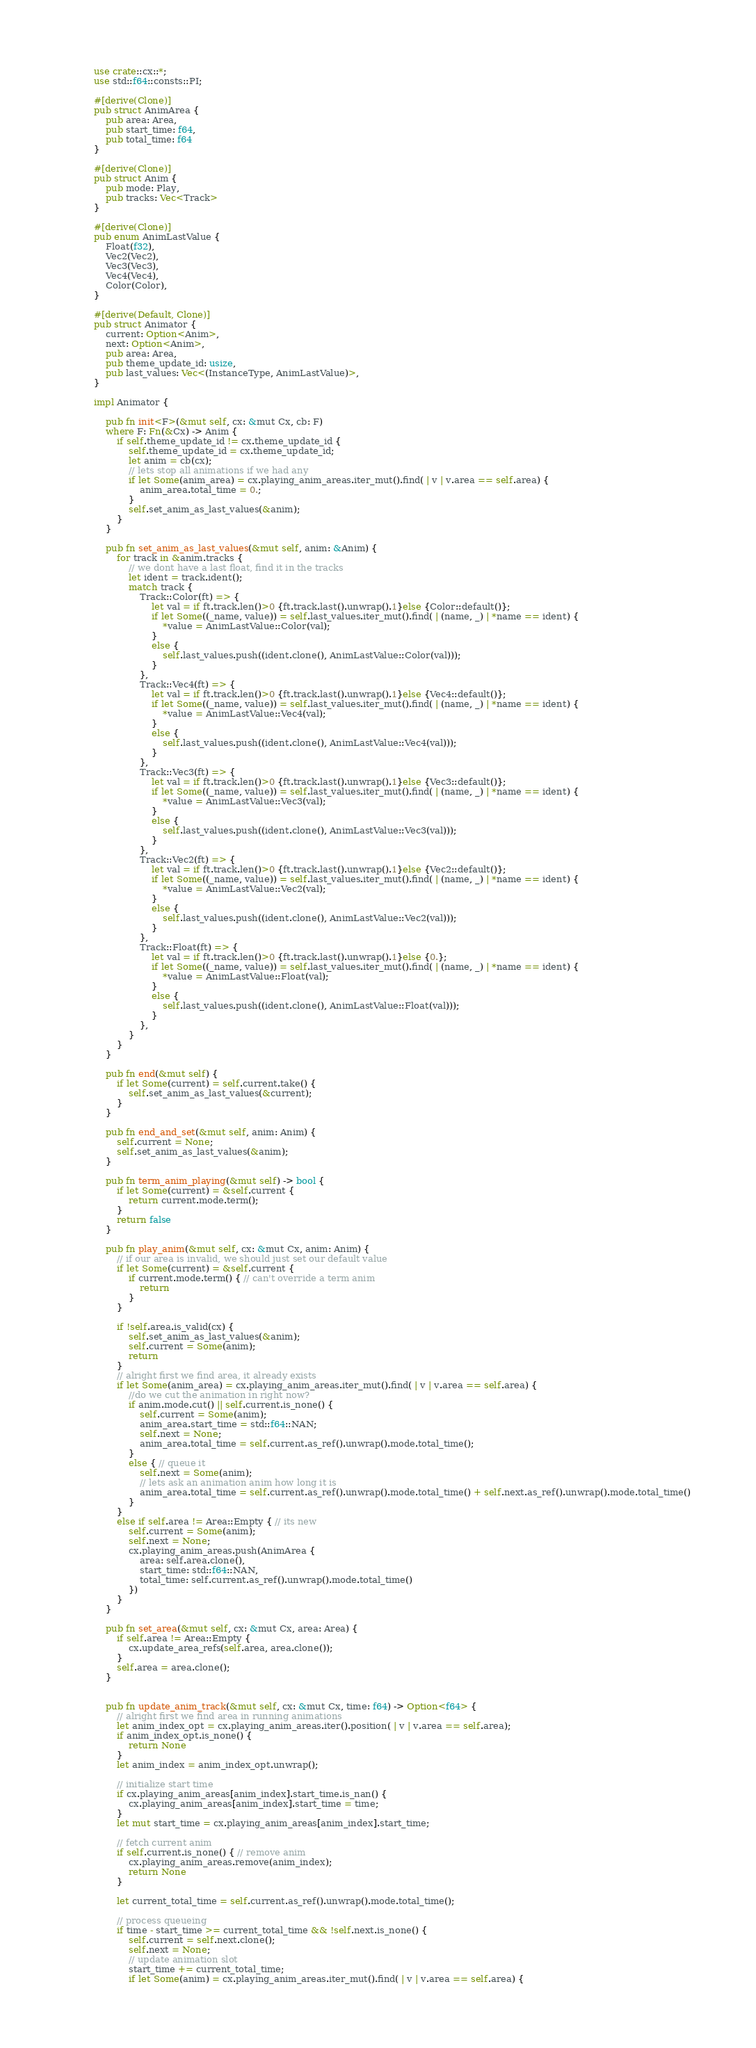Convert code to text. <code><loc_0><loc_0><loc_500><loc_500><_Rust_>use crate::cx::*;
use std::f64::consts::PI;

#[derive(Clone)]
pub struct AnimArea {
    pub area: Area,
    pub start_time: f64,
    pub total_time: f64
}

#[derive(Clone)]
pub struct Anim {
    pub mode: Play,
    pub tracks: Vec<Track>
}

#[derive(Clone)]
pub enum AnimLastValue {
    Float(f32),
    Vec2(Vec2),
    Vec3(Vec3),
    Vec4(Vec4),
    Color(Color),
}

#[derive(Default, Clone)]
pub struct Animator {
    current: Option<Anim>,
    next: Option<Anim>,
    pub area: Area,
    pub theme_update_id: usize,
    pub last_values: Vec<(InstanceType, AnimLastValue)>,
}

impl Animator {

    pub fn init<F>(&mut self, cx: &mut Cx, cb: F)
    where F: Fn(&Cx) -> Anim {
        if self.theme_update_id != cx.theme_update_id {
            self.theme_update_id = cx.theme_update_id;
            let anim = cb(cx);
            // lets stop all animations if we had any
            if let Some(anim_area) = cx.playing_anim_areas.iter_mut().find( | v | v.area == self.area) {
                anim_area.total_time = 0.;
            }
            self.set_anim_as_last_values(&anim);
        }
    }
    
    pub fn set_anim_as_last_values(&mut self, anim: &Anim) {
        for track in &anim.tracks {
            // we dont have a last float, find it in the tracks
            let ident = track.ident();
            match track {
                Track::Color(ft) => {
                    let val = if ft.track.len()>0 {ft.track.last().unwrap().1}else {Color::default()};
                    if let Some((_name, value)) = self.last_values.iter_mut().find( | (name, _) | *name == ident) {
                        *value = AnimLastValue::Color(val);
                    }
                    else {
                        self.last_values.push((ident.clone(), AnimLastValue::Color(val)));
                    }
                },
                Track::Vec4(ft) => {
                    let val = if ft.track.len()>0 {ft.track.last().unwrap().1}else {Vec4::default()};
                    if let Some((_name, value)) = self.last_values.iter_mut().find( | (name, _) | *name == ident) {
                        *value = AnimLastValue::Vec4(val);
                    }
                    else {
                        self.last_values.push((ident.clone(), AnimLastValue::Vec4(val)));
                    }
                },
                Track::Vec3(ft) => {
                    let val = if ft.track.len()>0 {ft.track.last().unwrap().1}else {Vec3::default()};
                    if let Some((_name, value)) = self.last_values.iter_mut().find( | (name, _) | *name == ident) {
                        *value = AnimLastValue::Vec3(val);
                    }
                    else {
                        self.last_values.push((ident.clone(), AnimLastValue::Vec3(val)));
                    }
                },
                Track::Vec2(ft) => {
                    let val = if ft.track.len()>0 {ft.track.last().unwrap().1}else {Vec2::default()};
                    if let Some((_name, value)) = self.last_values.iter_mut().find( | (name, _) | *name == ident) {
                        *value = AnimLastValue::Vec2(val);
                    }
                    else {
                        self.last_values.push((ident.clone(), AnimLastValue::Vec2(val)));
                    }
                },
                Track::Float(ft) => {
                    let val = if ft.track.len()>0 {ft.track.last().unwrap().1}else {0.};
                    if let Some((_name, value)) = self.last_values.iter_mut().find( | (name, _) | *name == ident) {
                        *value = AnimLastValue::Float(val);
                    }
                    else {
                        self.last_values.push((ident.clone(), AnimLastValue::Float(val)));
                    }
                },
            }
        }
    }
    
    pub fn end(&mut self) {
        if let Some(current) = self.current.take() {
            self.set_anim_as_last_values(&current);
        }
    }
    
    pub fn end_and_set(&mut self, anim: Anim) {
        self.current = None;
        self.set_anim_as_last_values(&anim);
    }
    
    pub fn term_anim_playing(&mut self) -> bool {
        if let Some(current) = &self.current {
            return current.mode.term();
        }
        return false
    }
    
    pub fn play_anim(&mut self, cx: &mut Cx, anim: Anim) {
        // if our area is invalid, we should just set our default value
        if let Some(current) = &self.current {
            if current.mode.term() { // can't override a term anim
                return
            }
        }
        
        if !self.area.is_valid(cx) {
            self.set_anim_as_last_values(&anim);
            self.current = Some(anim);
            return
        }
        // alright first we find area, it already exists
        if let Some(anim_area) = cx.playing_anim_areas.iter_mut().find( | v | v.area == self.area) {
            //do we cut the animation in right now?
            if anim.mode.cut() || self.current.is_none() {
                self.current = Some(anim);
                anim_area.start_time = std::f64::NAN;
                self.next = None;
                anim_area.total_time = self.current.as_ref().unwrap().mode.total_time();
            }
            else { // queue it
                self.next = Some(anim);
                // lets ask an animation anim how long it is
                anim_area.total_time = self.current.as_ref().unwrap().mode.total_time() + self.next.as_ref().unwrap().mode.total_time()
            }
        }
        else if self.area != Area::Empty { // its new
            self.current = Some(anim);
            self.next = None;
            cx.playing_anim_areas.push(AnimArea {
                area: self.area.clone(),
                start_time: std::f64::NAN,
                total_time: self.current.as_ref().unwrap().mode.total_time()
            })
        }
    }
    
    pub fn set_area(&mut self, cx: &mut Cx, area: Area) {
        if self.area != Area::Empty {
            cx.update_area_refs(self.area, area.clone());
        }
        self.area = area.clone();
    }
    
    
    pub fn update_anim_track(&mut self, cx: &mut Cx, time: f64) -> Option<f64> {
        // alright first we find area in running animations
        let anim_index_opt = cx.playing_anim_areas.iter().position( | v | v.area == self.area);
        if anim_index_opt.is_none() {
            return None
        }
        let anim_index = anim_index_opt.unwrap();
        
        // initialize start time
        if cx.playing_anim_areas[anim_index].start_time.is_nan() {
            cx.playing_anim_areas[anim_index].start_time = time;
        }
        let mut start_time = cx.playing_anim_areas[anim_index].start_time;
        
        // fetch current anim
        if self.current.is_none() { // remove anim
            cx.playing_anim_areas.remove(anim_index);
            return None
        }
        
        let current_total_time = self.current.as_ref().unwrap().mode.total_time();
        
        // process queueing
        if time - start_time >= current_total_time && !self.next.is_none() {
            self.current = self.next.clone();
            self.next = None;
            // update animation slot
            start_time += current_total_time;
            if let Some(anim) = cx.playing_anim_areas.iter_mut().find( | v | v.area == self.area) {</code> 